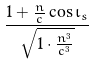Convert formula to latex. <formula><loc_0><loc_0><loc_500><loc_500>\frac { 1 + \frac { n } { c } \cos \iota _ { s } } { \sqrt { 1 \cdot \frac { n ^ { 3 } } { c ^ { 3 } } } }</formula> 